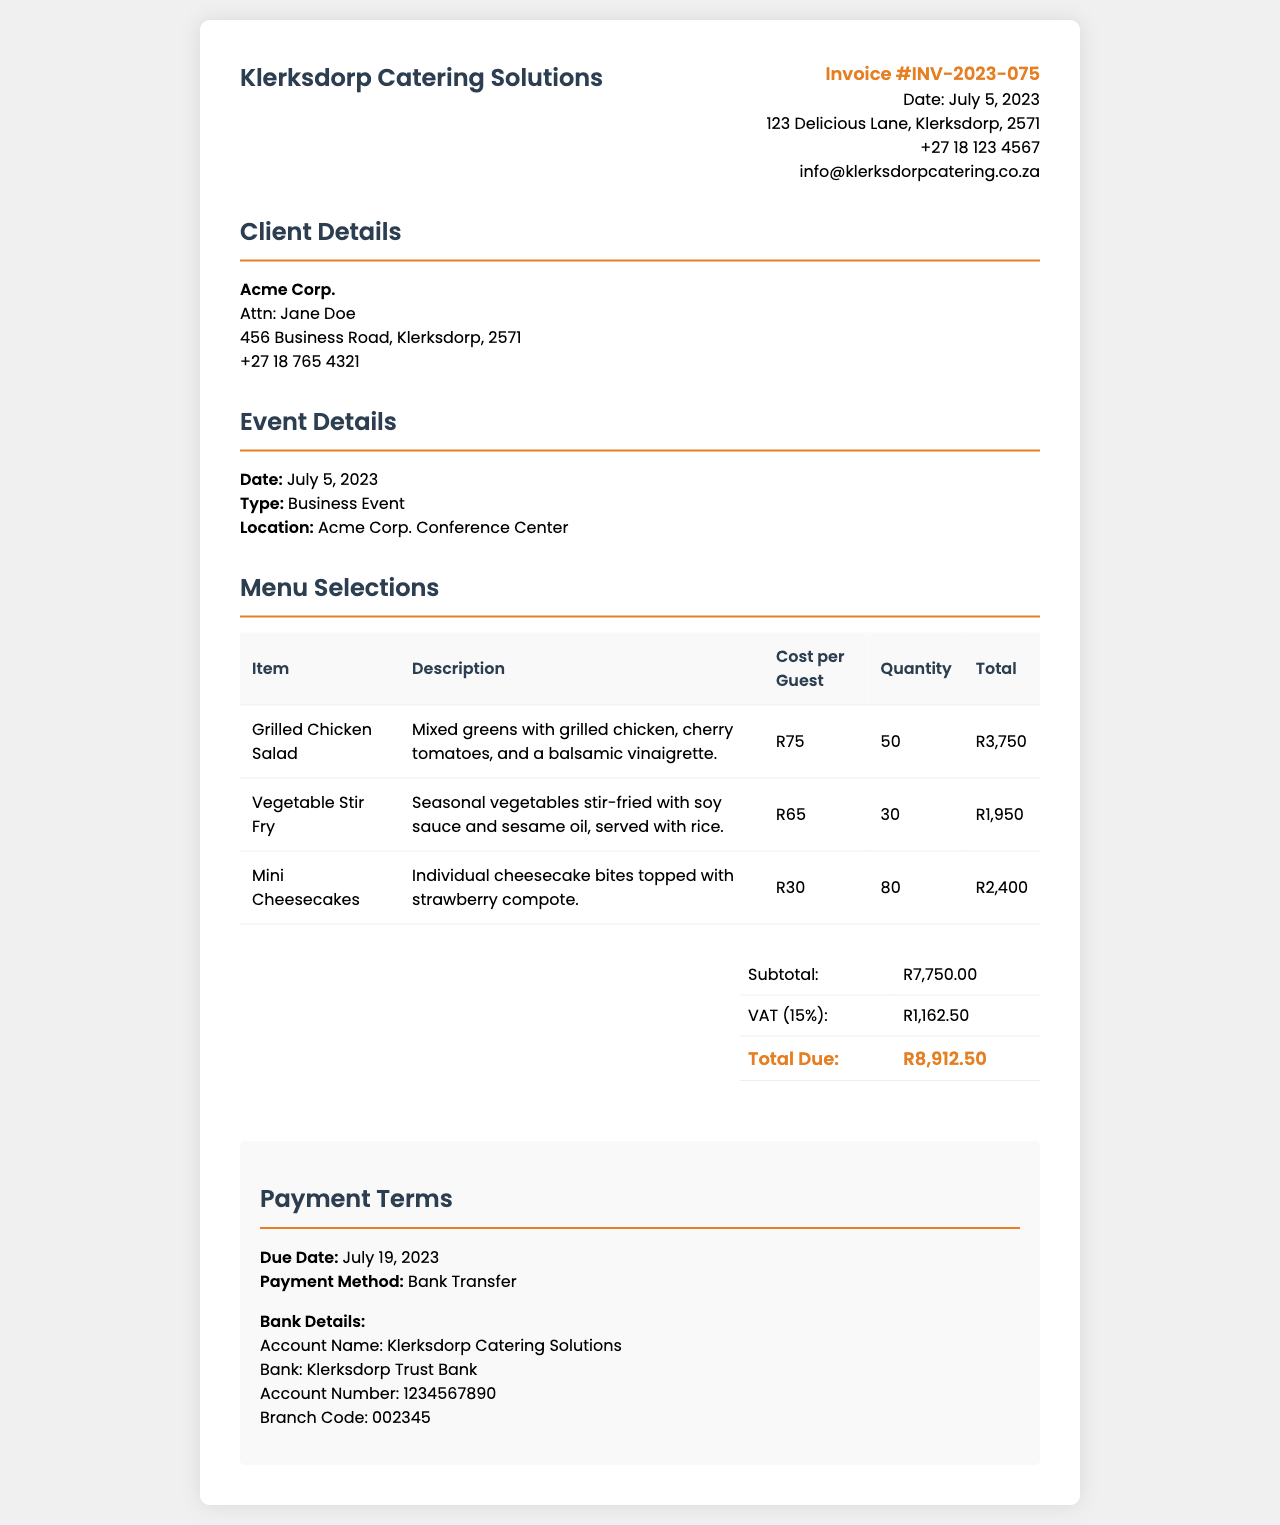what is the invoice number? The invoice number is mentioned at the top right section of the document.
Answer: INV-2023-075 who is the client? The client's name is provided in the client details section of the document.
Answer: Acme Corp what is the total due amount? The total due is shown in the total section of the document, summing up all costs.
Answer: R8,912.50 when is the payment due date? The due date for payment is indicated in the payment terms section of the document.
Answer: July 19, 2023 how many guests were served Grilled Chicken Salad? The quantity of Grilled Chicken Salad served is stated in the menu selections table.
Answer: 50 what is the VAT percentage applied? The VAT percentage is noted beside the VAT amount in the total section of the document.
Answer: 15% what is the cost per guest for the Mini Cheesecakes? The individual cost per guest for Mini Cheesecakes is listed in the menu selections table.
Answer: R30 what type of event was catered? The type of event is specified in the event details section of the document.
Answer: Business Event where is the catering company's office located? The catering company's address is mentioned at the top of the invoice.
Answer: 123 Delicious Lane, Klerksdorp, 2571 what is the main payment method? The payment method is described in the payment terms section.
Answer: Bank Transfer 